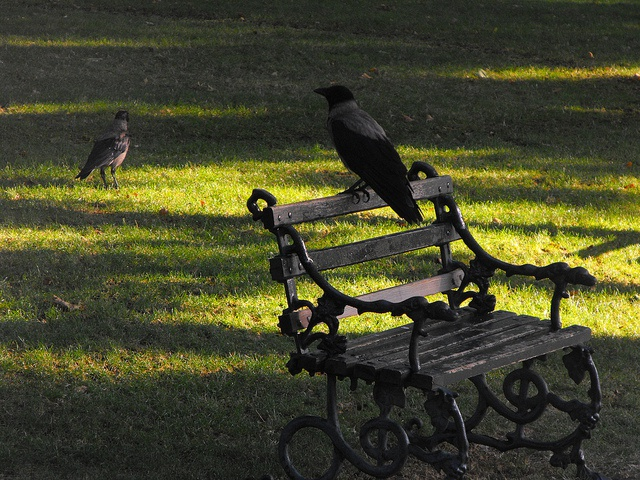Describe the objects in this image and their specific colors. I can see bench in black, gray, darkgreen, and olive tones, bird in black, gray, and darkgreen tones, and bird in black, gray, and darkgreen tones in this image. 